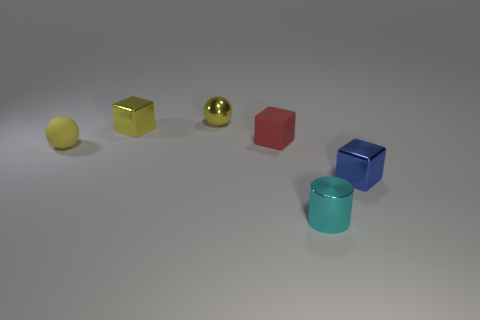Is the color of the small thing that is on the right side of the cyan metallic cylinder the same as the tiny shiny cylinder?
Offer a terse response. No. What shape is the cyan object that is the same material as the small blue block?
Provide a short and direct response. Cylinder. What color is the tiny object that is in front of the tiny rubber cube and to the left of the tiny cyan metallic object?
Provide a succinct answer. Yellow. There is a cube that is on the left side of the tiny sphere to the right of the yellow matte thing; what size is it?
Give a very brief answer. Small. Are there any metal balls of the same color as the small matte sphere?
Ensure brevity in your answer.  Yes. Is the number of yellow matte objects behind the small metallic cylinder the same as the number of small brown cylinders?
Your response must be concise. No. What number of tiny cyan rubber things are there?
Your answer should be compact. 0. What shape is the tiny metallic thing that is both behind the cylinder and on the right side of the tiny red matte object?
Offer a terse response. Cube. Do the rubber object to the right of the tiny yellow matte ball and the object that is in front of the small blue object have the same color?
Ensure brevity in your answer.  No. What is the size of the block that is the same color as the tiny rubber ball?
Offer a very short reply. Small. 